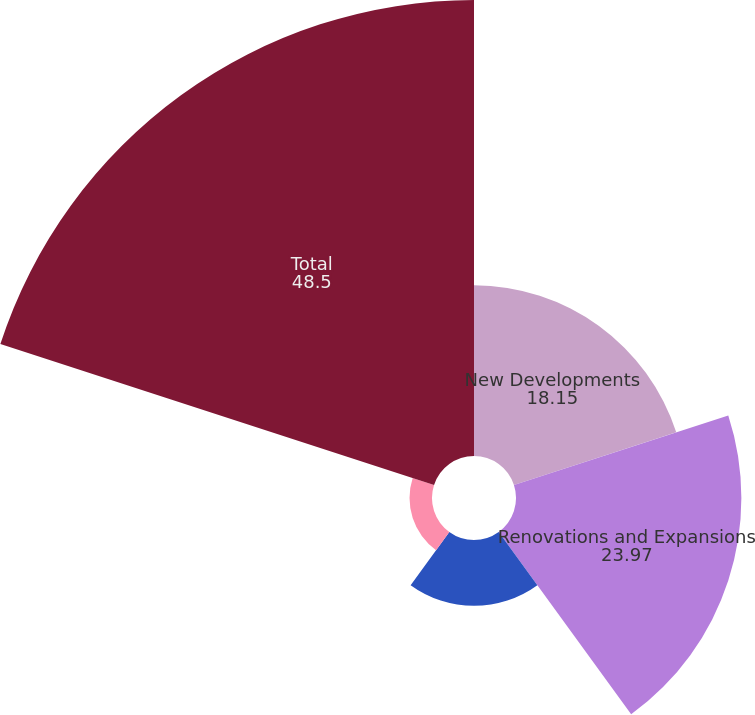Convert chart to OTSL. <chart><loc_0><loc_0><loc_500><loc_500><pie_chart><fcel>New Developments<fcel>Renovations and Expansions<fcel>Tenant Allowances<fcel>Operational Capital<fcel>Total<nl><fcel>18.15%<fcel>23.97%<fcel>7.0%<fcel>2.39%<fcel>48.5%<nl></chart> 